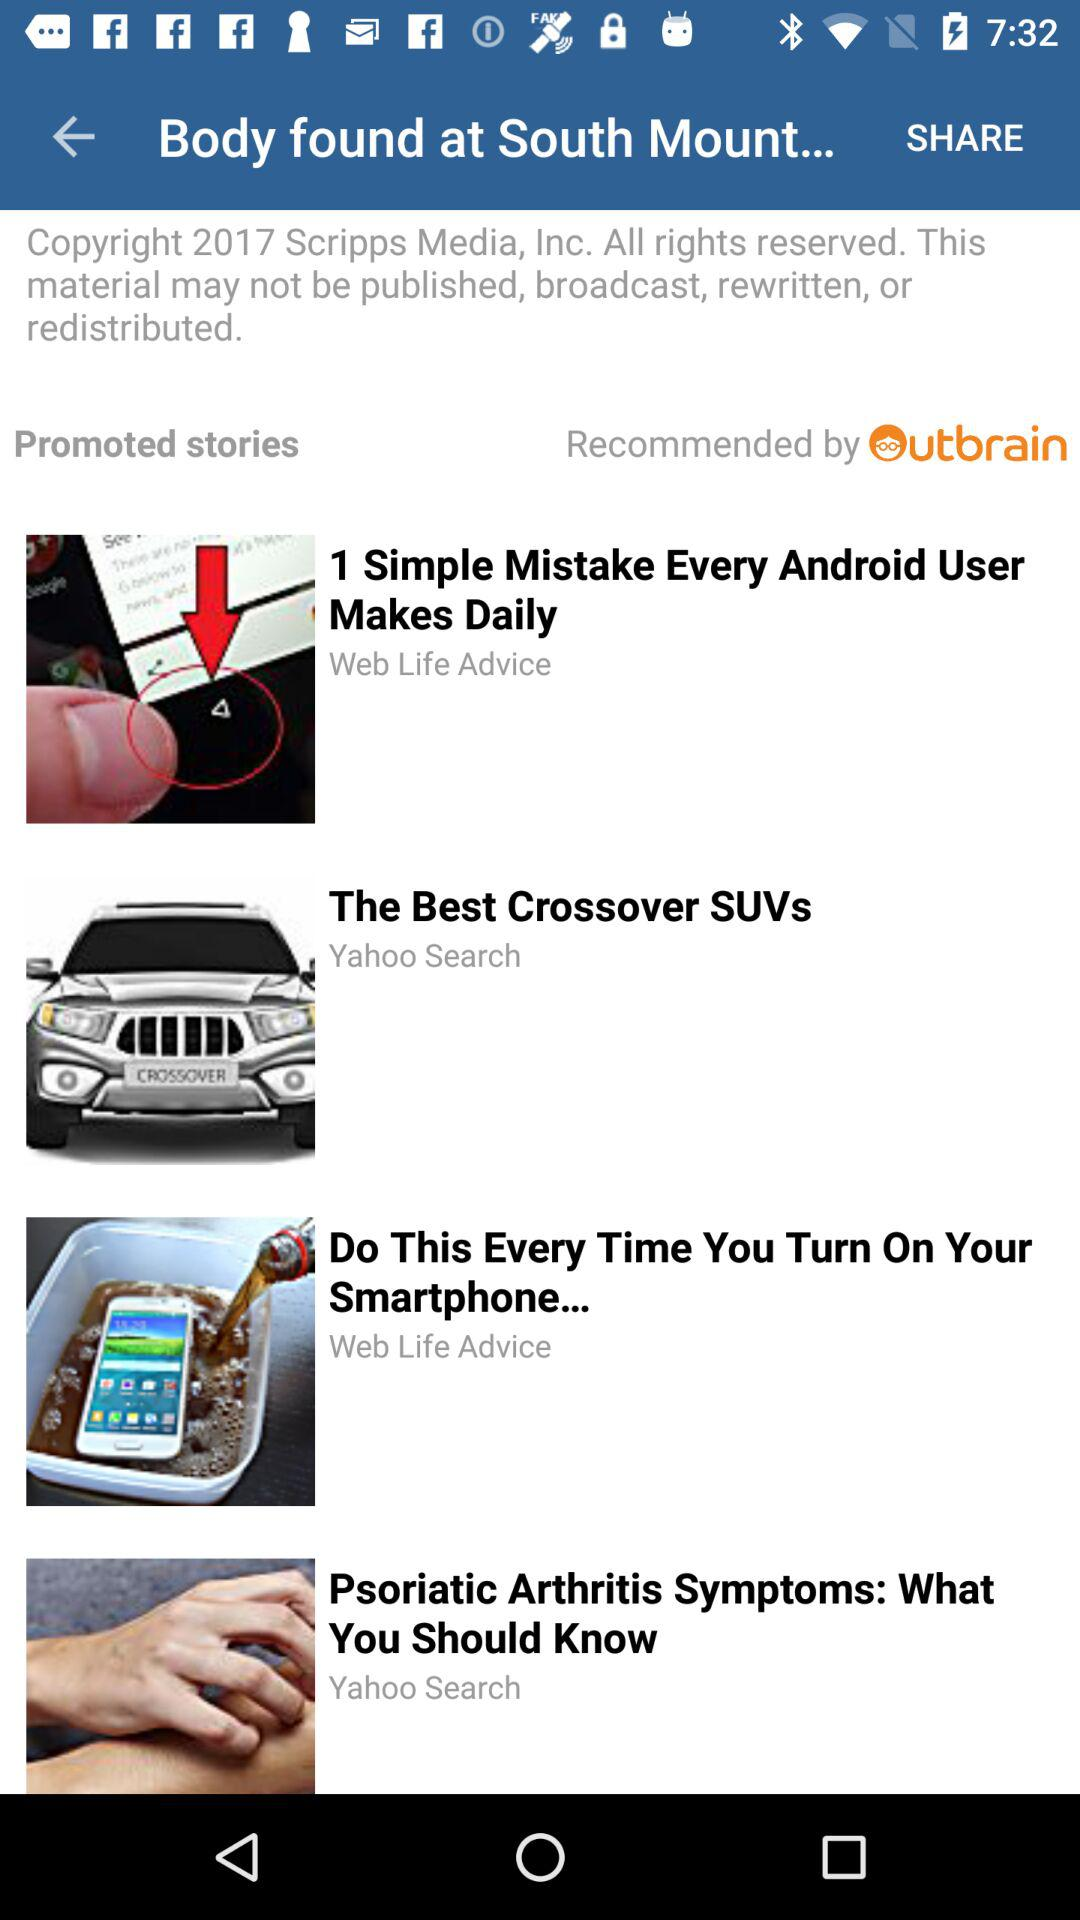How many stories are there in total?
Answer the question using a single word or phrase. 4 